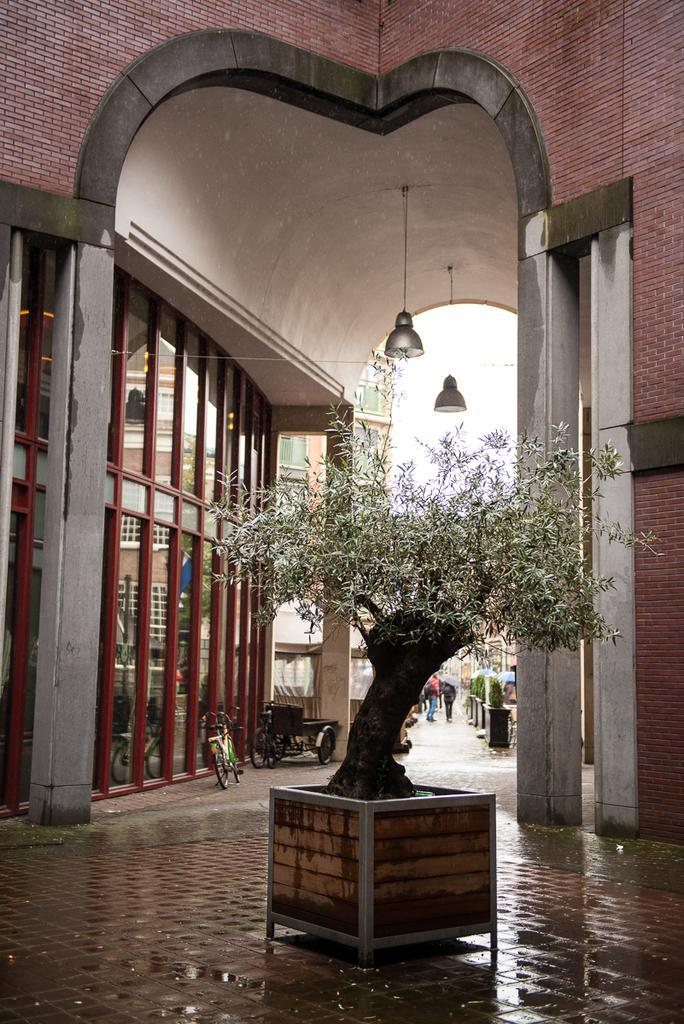Can you describe this image briefly? In this picture in the center there is a plant. In the background there are buildings and vehicles and there are lights hanging and there are persons. 